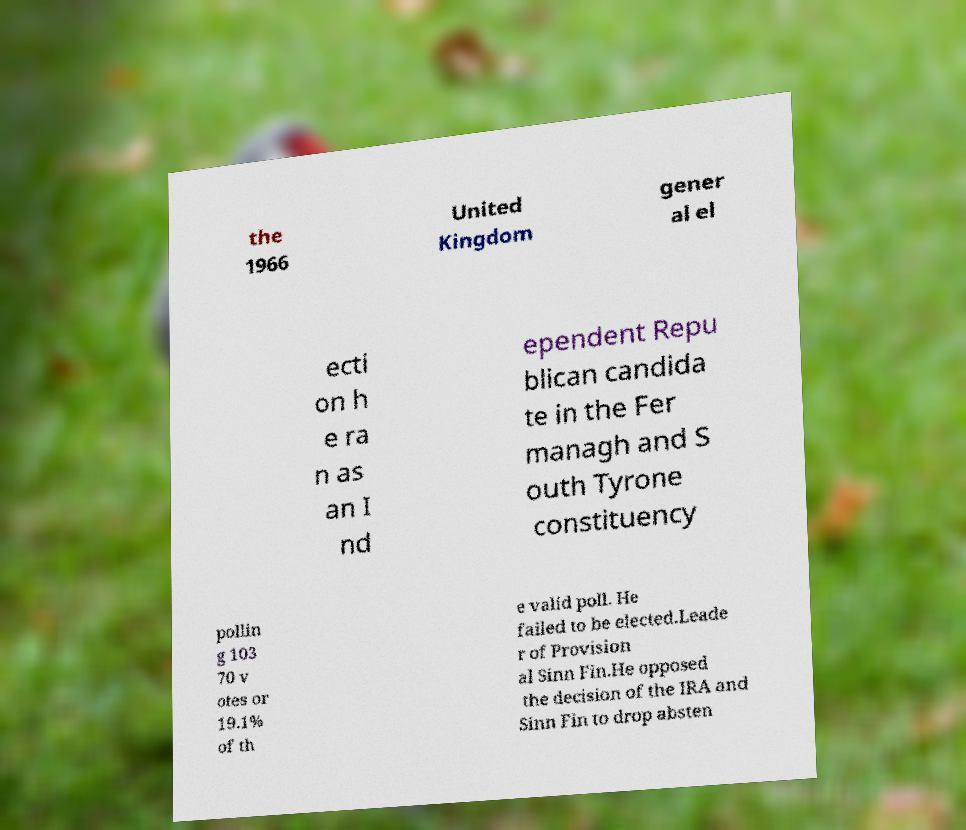I need the written content from this picture converted into text. Can you do that? the 1966 United Kingdom gener al el ecti on h e ra n as an I nd ependent Repu blican candida te in the Fer managh and S outh Tyrone constituency pollin g 103 70 v otes or 19.1% of th e valid poll. He failed to be elected.Leade r of Provision al Sinn Fin.He opposed the decision of the IRA and Sinn Fin to drop absten 